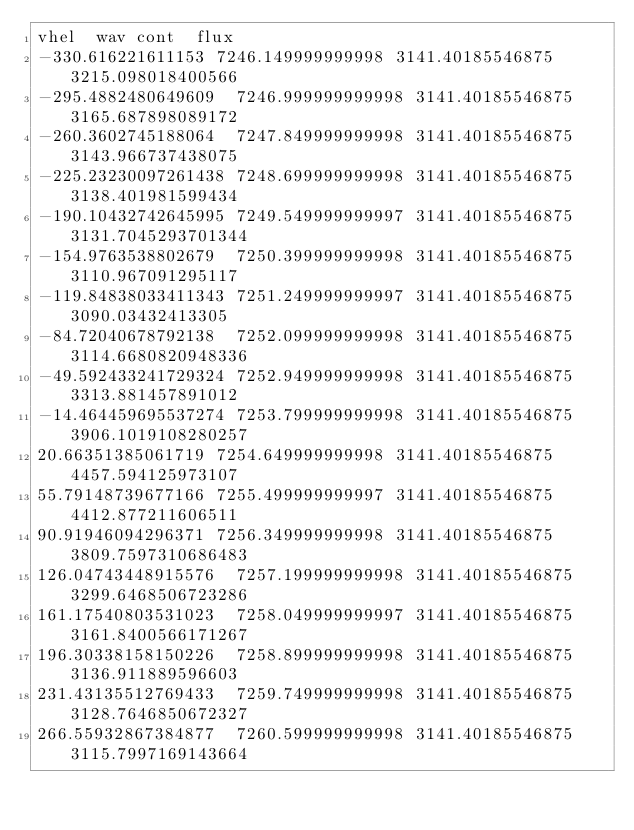<code> <loc_0><loc_0><loc_500><loc_500><_SQL_>vhel	wav	cont	flux
-330.616221611153	7246.149999999998	3141.40185546875	3215.098018400566
-295.4882480649609	7246.999999999998	3141.40185546875	3165.687898089172
-260.3602745188064	7247.849999999998	3141.40185546875	3143.966737438075
-225.23230097261438	7248.699999999998	3141.40185546875	3138.401981599434
-190.10432742645995	7249.549999999997	3141.40185546875	3131.7045293701344
-154.9763538802679	7250.399999999998	3141.40185546875	3110.967091295117
-119.84838033411343	7251.249999999997	3141.40185546875	3090.03432413305
-84.72040678792138	7252.099999999998	3141.40185546875	3114.6680820948336
-49.592433241729324	7252.949999999998	3141.40185546875	3313.881457891012
-14.464459695537274	7253.799999999998	3141.40185546875	3906.1019108280257
20.66351385061719	7254.649999999998	3141.40185546875	4457.594125973107
55.79148739677166	7255.499999999997	3141.40185546875	4412.877211606511
90.91946094296371	7256.349999999998	3141.40185546875	3809.7597310686483
126.04743448915576	7257.199999999998	3141.40185546875	3299.6468506723286
161.17540803531023	7258.049999999997	3141.40185546875	3161.8400566171267
196.30338158150226	7258.899999999998	3141.40185546875	3136.911889596603
231.43135512769433	7259.749999999998	3141.40185546875	3128.7646850672327
266.55932867384877	7260.599999999998	3141.40185546875	3115.7997169143664</code> 